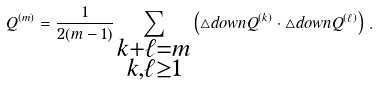Convert formula to latex. <formula><loc_0><loc_0><loc_500><loc_500>Q ^ { ( m ) } = \frac { 1 } { 2 ( m - 1 ) } \sum _ { \substack { k + \ell = m \\ k , \ell \geq 1 } } \left ( \triangle d o w n Q ^ { ( k ) } \cdot \triangle d o w n Q ^ { ( \ell ) } \right ) \, .</formula> 